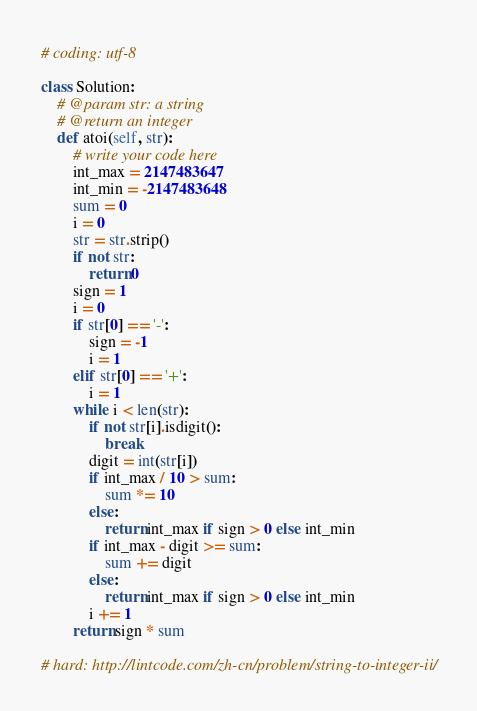Convert code to text. <code><loc_0><loc_0><loc_500><loc_500><_Python_># coding: utf-8

class Solution:
    # @param str: a string
    # @return an integer
    def atoi(self, str):
        # write your code here
        int_max = 2147483647
        int_min = -2147483648
        sum = 0
        i = 0
        str = str.strip()
        if not str:
            return 0
        sign = 1
        i = 0
        if str[0] == '-':
            sign = -1
            i = 1
        elif str[0] == '+':
            i = 1
        while i < len(str):
            if not str[i].isdigit():
                break
            digit = int(str[i])
            if int_max / 10 > sum:
                sum *= 10
            else:
                return int_max if sign > 0 else int_min
            if int_max - digit >= sum:
                sum += digit
            else:
                return int_max if sign > 0 else int_min
            i += 1
        return sign * sum

# hard: http://lintcode.com/zh-cn/problem/string-to-integer-ii/
</code> 